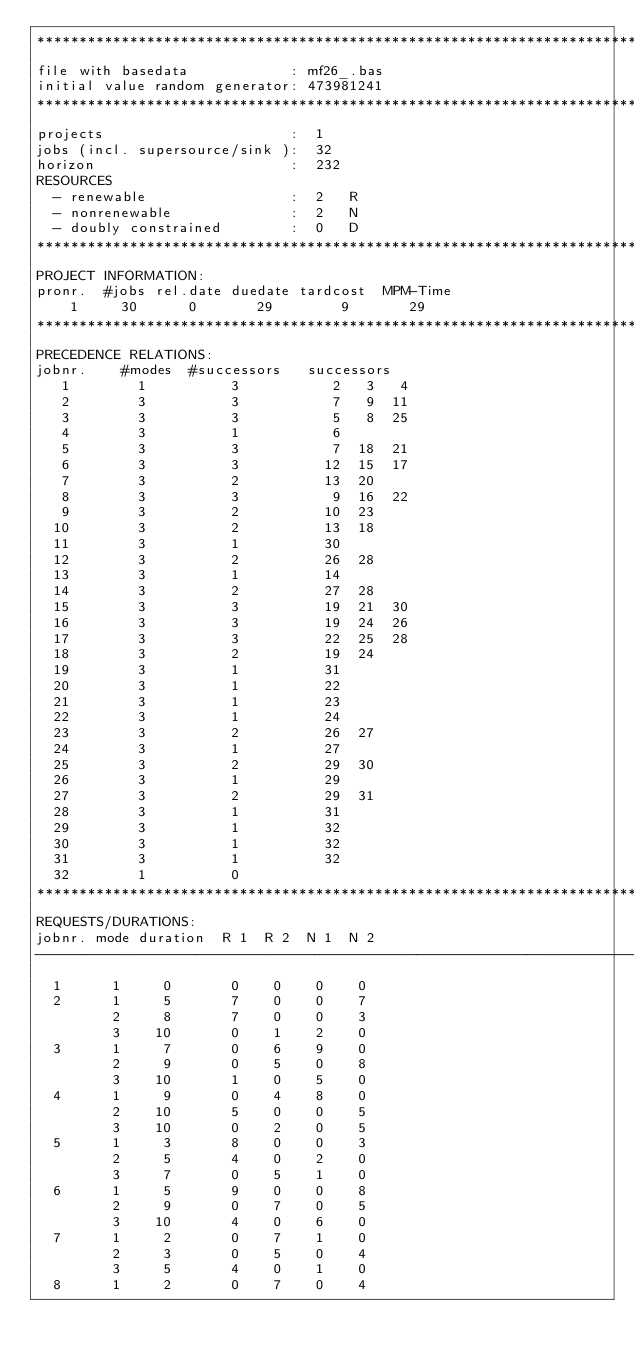Convert code to text. <code><loc_0><loc_0><loc_500><loc_500><_ObjectiveC_>************************************************************************
file with basedata            : mf26_.bas
initial value random generator: 473981241
************************************************************************
projects                      :  1
jobs (incl. supersource/sink ):  32
horizon                       :  232
RESOURCES
  - renewable                 :  2   R
  - nonrenewable              :  2   N
  - doubly constrained        :  0   D
************************************************************************
PROJECT INFORMATION:
pronr.  #jobs rel.date duedate tardcost  MPM-Time
    1     30      0       29        9       29
************************************************************************
PRECEDENCE RELATIONS:
jobnr.    #modes  #successors   successors
   1        1          3           2   3   4
   2        3          3           7   9  11
   3        3          3           5   8  25
   4        3          1           6
   5        3          3           7  18  21
   6        3          3          12  15  17
   7        3          2          13  20
   8        3          3           9  16  22
   9        3          2          10  23
  10        3          2          13  18
  11        3          1          30
  12        3          2          26  28
  13        3          1          14
  14        3          2          27  28
  15        3          3          19  21  30
  16        3          3          19  24  26
  17        3          3          22  25  28
  18        3          2          19  24
  19        3          1          31
  20        3          1          22
  21        3          1          23
  22        3          1          24
  23        3          2          26  27
  24        3          1          27
  25        3          2          29  30
  26        3          1          29
  27        3          2          29  31
  28        3          1          31
  29        3          1          32
  30        3          1          32
  31        3          1          32
  32        1          0        
************************************************************************
REQUESTS/DURATIONS:
jobnr. mode duration  R 1  R 2  N 1  N 2
------------------------------------------------------------------------
  1      1     0       0    0    0    0
  2      1     5       7    0    0    7
         2     8       7    0    0    3
         3    10       0    1    2    0
  3      1     7       0    6    9    0
         2     9       0    5    0    8
         3    10       1    0    5    0
  4      1     9       0    4    8    0
         2    10       5    0    0    5
         3    10       0    2    0    5
  5      1     3       8    0    0    3
         2     5       4    0    2    0
         3     7       0    5    1    0
  6      1     5       9    0    0    8
         2     9       0    7    0    5
         3    10       4    0    6    0
  7      1     2       0    7    1    0
         2     3       0    5    0    4
         3     5       4    0    1    0
  8      1     2       0    7    0    4</code> 